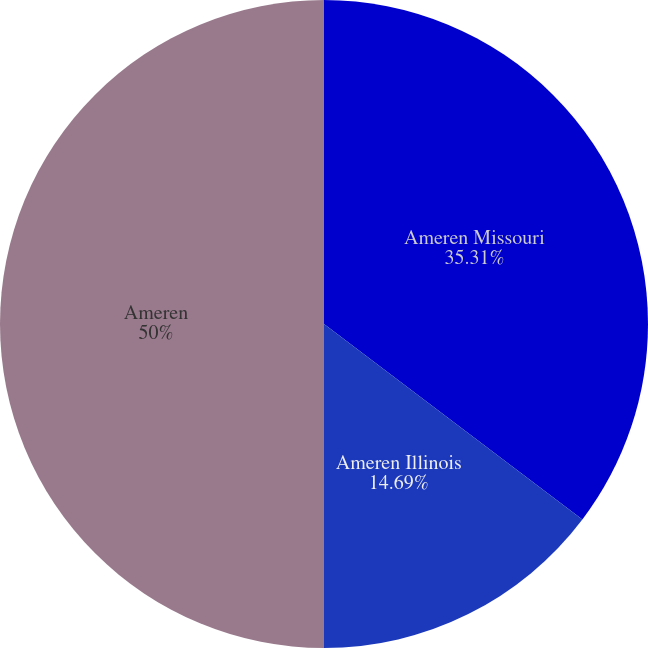Convert chart. <chart><loc_0><loc_0><loc_500><loc_500><pie_chart><fcel>Ameren Missouri<fcel>Ameren Illinois<fcel>Ameren<nl><fcel>35.31%<fcel>14.69%<fcel>50.0%<nl></chart> 